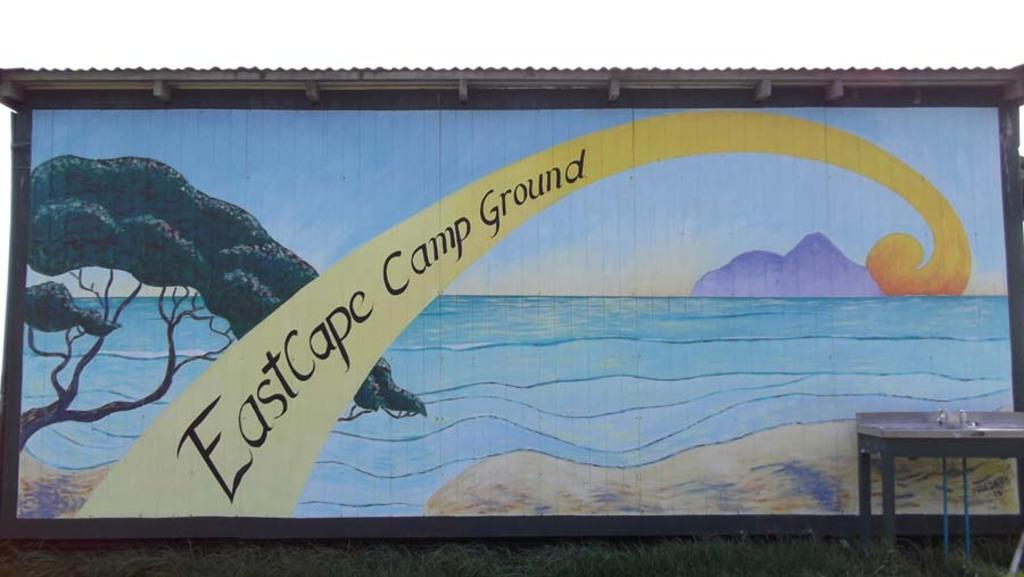What is hanging on the wall in the image? There is a painting on a wall in the image. What is located on the ground in the image? There is a table on the ground in the image. What type of surface covers the ground in the image? The ground is covered with grass. What shape is the amusement park in the image? There is no amusement park present in the image. How many chains are hanging from the painting in the image? There are no chains hanging from the painting in the image. 